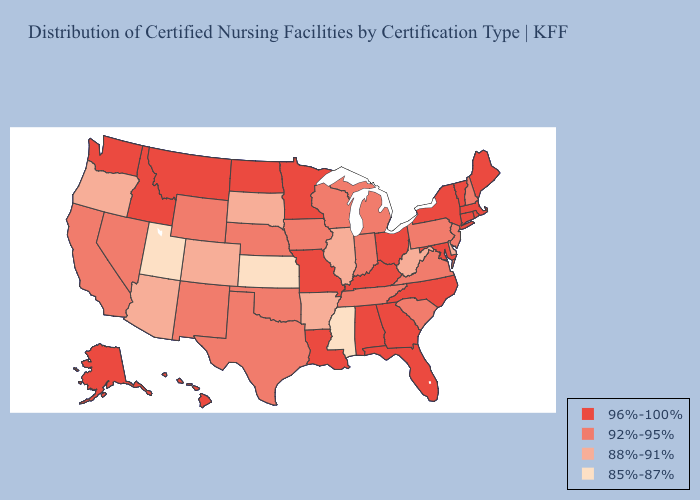What is the lowest value in states that border Idaho?
Write a very short answer. 85%-87%. What is the lowest value in states that border New Mexico?
Concise answer only. 85%-87%. Does North Dakota have the lowest value in the MidWest?
Answer briefly. No. What is the highest value in the South ?
Write a very short answer. 96%-100%. Name the states that have a value in the range 85%-87%?
Concise answer only. Kansas, Mississippi, Utah. Does the map have missing data?
Give a very brief answer. No. Name the states that have a value in the range 85%-87%?
Answer briefly. Kansas, Mississippi, Utah. Does Nevada have a lower value than Delaware?
Quick response, please. No. What is the value of South Carolina?
Write a very short answer. 92%-95%. What is the value of Ohio?
Answer briefly. 96%-100%. Name the states that have a value in the range 92%-95%?
Short answer required. California, Indiana, Iowa, Michigan, Nebraska, Nevada, New Hampshire, New Jersey, New Mexico, Oklahoma, Pennsylvania, South Carolina, Tennessee, Texas, Virginia, Wisconsin, Wyoming. What is the highest value in states that border Colorado?
Quick response, please. 92%-95%. Does Illinois have a higher value than North Carolina?
Concise answer only. No. Does Mississippi have the lowest value in the South?
Answer briefly. Yes. How many symbols are there in the legend?
Quick response, please. 4. 